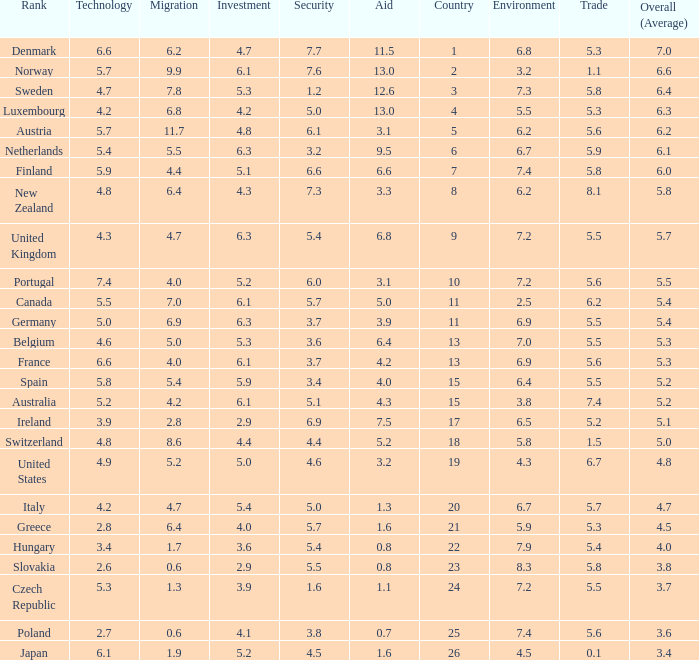What is the migration rating when trade is 5.7? 4.7. Could you parse the entire table as a dict? {'header': ['Rank', 'Technology', 'Migration', 'Investment', 'Security', 'Aid', 'Country', 'Environment', 'Trade', 'Overall (Average)'], 'rows': [['Denmark', '6.6', '6.2', '4.7', '7.7', '11.5', '1', '6.8', '5.3', '7.0'], ['Norway', '5.7', '9.9', '6.1', '7.6', '13.0', '2', '3.2', '1.1', '6.6'], ['Sweden', '4.7', '7.8', '5.3', '1.2', '12.6', '3', '7.3', '5.8', '6.4'], ['Luxembourg', '4.2', '6.8', '4.2', '5.0', '13.0', '4', '5.5', '5.3', '6.3'], ['Austria', '5.7', '11.7', '4.8', '6.1', '3.1', '5', '6.2', '5.6', '6.2'], ['Netherlands', '5.4', '5.5', '6.3', '3.2', '9.5', '6', '6.7', '5.9', '6.1'], ['Finland', '5.9', '4.4', '5.1', '6.6', '6.6', '7', '7.4', '5.8', '6.0'], ['New Zealand', '4.8', '6.4', '4.3', '7.3', '3.3', '8', '6.2', '8.1', '5.8'], ['United Kingdom', '4.3', '4.7', '6.3', '5.4', '6.8', '9', '7.2', '5.5', '5.7'], ['Portugal', '7.4', '4.0', '5.2', '6.0', '3.1', '10', '7.2', '5.6', '5.5'], ['Canada', '5.5', '7.0', '6.1', '5.7', '5.0', '11', '2.5', '6.2', '5.4'], ['Germany', '5.0', '6.9', '6.3', '3.7', '3.9', '11', '6.9', '5.5', '5.4'], ['Belgium', '4.6', '5.0', '5.3', '3.6', '6.4', '13', '7.0', '5.5', '5.3'], ['France', '6.6', '4.0', '6.1', '3.7', '4.2', '13', '6.9', '5.6', '5.3'], ['Spain', '5.8', '5.4', '5.9', '3.4', '4.0', '15', '6.4', '5.5', '5.2'], ['Australia', '5.2', '4.2', '6.1', '5.1', '4.3', '15', '3.8', '7.4', '5.2'], ['Ireland', '3.9', '2.8', '2.9', '6.9', '7.5', '17', '6.5', '5.2', '5.1'], ['Switzerland', '4.8', '8.6', '4.4', '4.4', '5.2', '18', '5.8', '1.5', '5.0'], ['United States', '4.9', '5.2', '5.0', '4.6', '3.2', '19', '4.3', '6.7', '4.8'], ['Italy', '4.2', '4.7', '5.4', '5.0', '1.3', '20', '6.7', '5.7', '4.7'], ['Greece', '2.8', '6.4', '4.0', '5.7', '1.6', '21', '5.9', '5.3', '4.5'], ['Hungary', '3.4', '1.7', '3.6', '5.4', '0.8', '22', '7.9', '5.4', '4.0'], ['Slovakia', '2.6', '0.6', '2.9', '5.5', '0.8', '23', '8.3', '5.8', '3.8'], ['Czech Republic', '5.3', '1.3', '3.9', '1.6', '1.1', '24', '7.2', '5.5', '3.7'], ['Poland', '2.7', '0.6', '4.1', '3.8', '0.7', '25', '7.4', '5.6', '3.6'], ['Japan', '6.1', '1.9', '5.2', '4.5', '1.6', '26', '4.5', '0.1', '3.4']]} 